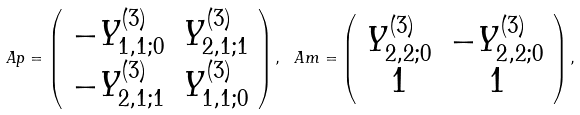<formula> <loc_0><loc_0><loc_500><loc_500>\ A p = \left ( \begin{array} { c c } - Y ^ { ( 3 ) } _ { 1 , 1 ; 0 } & Y ^ { ( 3 ) } _ { 2 , 1 ; 1 } \\ - Y ^ { ( 3 ) } _ { 2 , 1 ; 1 } & Y ^ { ( 3 ) } _ { 1 , 1 ; 0 } \end{array} \right ) , \ A m = \left ( \begin{array} { c c } Y ^ { ( 3 ) } _ { 2 , 2 ; 0 } & - Y ^ { ( 3 ) } _ { 2 , 2 ; 0 } \\ 1 & 1 \end{array} \right ) ,</formula> 